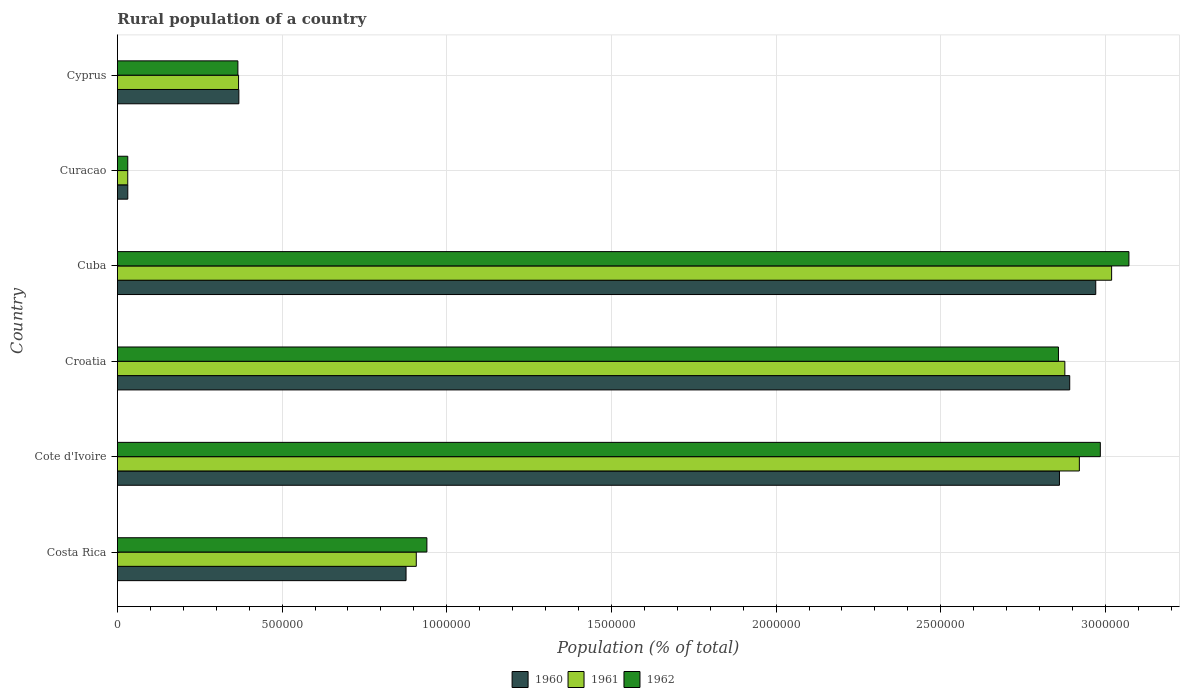How many different coloured bars are there?
Provide a short and direct response. 3. How many groups of bars are there?
Ensure brevity in your answer.  6. Are the number of bars on each tick of the Y-axis equal?
Your answer should be compact. Yes. What is the label of the 4th group of bars from the top?
Your response must be concise. Croatia. What is the rural population in 1961 in Croatia?
Ensure brevity in your answer.  2.88e+06. Across all countries, what is the maximum rural population in 1960?
Your answer should be compact. 2.97e+06. Across all countries, what is the minimum rural population in 1962?
Ensure brevity in your answer.  3.15e+04. In which country was the rural population in 1960 maximum?
Make the answer very short. Cuba. In which country was the rural population in 1961 minimum?
Ensure brevity in your answer.  Curacao. What is the total rural population in 1961 in the graph?
Your answer should be compact. 1.01e+07. What is the difference between the rural population in 1962 in Costa Rica and that in Cyprus?
Provide a succinct answer. 5.74e+05. What is the difference between the rural population in 1961 in Cyprus and the rural population in 1960 in Costa Rica?
Ensure brevity in your answer.  -5.09e+05. What is the average rural population in 1961 per country?
Provide a short and direct response. 1.69e+06. What is the difference between the rural population in 1962 and rural population in 1961 in Cuba?
Make the answer very short. 5.25e+04. What is the ratio of the rural population in 1961 in Costa Rica to that in Croatia?
Your answer should be very brief. 0.32. What is the difference between the highest and the second highest rural population in 1961?
Your answer should be compact. 9.80e+04. What is the difference between the highest and the lowest rural population in 1960?
Keep it short and to the point. 2.94e+06. What does the 3rd bar from the top in Cote d'Ivoire represents?
Give a very brief answer. 1960. Is it the case that in every country, the sum of the rural population in 1960 and rural population in 1961 is greater than the rural population in 1962?
Give a very brief answer. Yes. Are the values on the major ticks of X-axis written in scientific E-notation?
Ensure brevity in your answer.  No. Where does the legend appear in the graph?
Offer a very short reply. Bottom center. How many legend labels are there?
Offer a terse response. 3. What is the title of the graph?
Keep it short and to the point. Rural population of a country. Does "1993" appear as one of the legend labels in the graph?
Your answer should be compact. No. What is the label or title of the X-axis?
Offer a terse response. Population (% of total). What is the Population (% of total) in 1960 in Costa Rica?
Your answer should be very brief. 8.76e+05. What is the Population (% of total) in 1961 in Costa Rica?
Offer a terse response. 9.08e+05. What is the Population (% of total) in 1962 in Costa Rica?
Your answer should be compact. 9.40e+05. What is the Population (% of total) in 1960 in Cote d'Ivoire?
Ensure brevity in your answer.  2.86e+06. What is the Population (% of total) in 1961 in Cote d'Ivoire?
Make the answer very short. 2.92e+06. What is the Population (% of total) of 1962 in Cote d'Ivoire?
Give a very brief answer. 2.98e+06. What is the Population (% of total) of 1960 in Croatia?
Provide a short and direct response. 2.89e+06. What is the Population (% of total) in 1961 in Croatia?
Offer a very short reply. 2.88e+06. What is the Population (% of total) of 1962 in Croatia?
Keep it short and to the point. 2.86e+06. What is the Population (% of total) in 1960 in Cuba?
Keep it short and to the point. 2.97e+06. What is the Population (% of total) in 1961 in Cuba?
Provide a succinct answer. 3.02e+06. What is the Population (% of total) in 1962 in Cuba?
Offer a terse response. 3.07e+06. What is the Population (% of total) in 1960 in Curacao?
Offer a terse response. 3.16e+04. What is the Population (% of total) in 1961 in Curacao?
Offer a terse response. 3.14e+04. What is the Population (% of total) of 1962 in Curacao?
Provide a succinct answer. 3.15e+04. What is the Population (% of total) in 1960 in Cyprus?
Provide a short and direct response. 3.69e+05. What is the Population (% of total) in 1961 in Cyprus?
Make the answer very short. 3.68e+05. What is the Population (% of total) in 1962 in Cyprus?
Keep it short and to the point. 3.66e+05. Across all countries, what is the maximum Population (% of total) in 1960?
Ensure brevity in your answer.  2.97e+06. Across all countries, what is the maximum Population (% of total) of 1961?
Provide a succinct answer. 3.02e+06. Across all countries, what is the maximum Population (% of total) in 1962?
Provide a short and direct response. 3.07e+06. Across all countries, what is the minimum Population (% of total) in 1960?
Your response must be concise. 3.16e+04. Across all countries, what is the minimum Population (% of total) in 1961?
Your answer should be very brief. 3.14e+04. Across all countries, what is the minimum Population (% of total) in 1962?
Keep it short and to the point. 3.15e+04. What is the total Population (% of total) of 1960 in the graph?
Offer a terse response. 1.00e+07. What is the total Population (% of total) of 1961 in the graph?
Offer a very short reply. 1.01e+07. What is the total Population (% of total) of 1962 in the graph?
Your response must be concise. 1.03e+07. What is the difference between the Population (% of total) of 1960 in Costa Rica and that in Cote d'Ivoire?
Give a very brief answer. -1.98e+06. What is the difference between the Population (% of total) of 1961 in Costa Rica and that in Cote d'Ivoire?
Your answer should be compact. -2.01e+06. What is the difference between the Population (% of total) of 1962 in Costa Rica and that in Cote d'Ivoire?
Ensure brevity in your answer.  -2.04e+06. What is the difference between the Population (% of total) in 1960 in Costa Rica and that in Croatia?
Your answer should be compact. -2.02e+06. What is the difference between the Population (% of total) of 1961 in Costa Rica and that in Croatia?
Make the answer very short. -1.97e+06. What is the difference between the Population (% of total) in 1962 in Costa Rica and that in Croatia?
Your response must be concise. -1.92e+06. What is the difference between the Population (% of total) of 1960 in Costa Rica and that in Cuba?
Your answer should be very brief. -2.09e+06. What is the difference between the Population (% of total) of 1961 in Costa Rica and that in Cuba?
Keep it short and to the point. -2.11e+06. What is the difference between the Population (% of total) of 1962 in Costa Rica and that in Cuba?
Provide a short and direct response. -2.13e+06. What is the difference between the Population (% of total) of 1960 in Costa Rica and that in Curacao?
Your answer should be compact. 8.45e+05. What is the difference between the Population (% of total) of 1961 in Costa Rica and that in Curacao?
Keep it short and to the point. 8.76e+05. What is the difference between the Population (% of total) in 1962 in Costa Rica and that in Curacao?
Your answer should be very brief. 9.08e+05. What is the difference between the Population (% of total) of 1960 in Costa Rica and that in Cyprus?
Provide a short and direct response. 5.08e+05. What is the difference between the Population (% of total) in 1961 in Costa Rica and that in Cyprus?
Give a very brief answer. 5.40e+05. What is the difference between the Population (% of total) in 1962 in Costa Rica and that in Cyprus?
Ensure brevity in your answer.  5.74e+05. What is the difference between the Population (% of total) of 1960 in Cote d'Ivoire and that in Croatia?
Your answer should be compact. -3.12e+04. What is the difference between the Population (% of total) of 1961 in Cote d'Ivoire and that in Croatia?
Your answer should be very brief. 4.41e+04. What is the difference between the Population (% of total) in 1962 in Cote d'Ivoire and that in Croatia?
Offer a terse response. 1.27e+05. What is the difference between the Population (% of total) in 1960 in Cote d'Ivoire and that in Cuba?
Make the answer very short. -1.10e+05. What is the difference between the Population (% of total) in 1961 in Cote d'Ivoire and that in Cuba?
Offer a terse response. -9.80e+04. What is the difference between the Population (% of total) of 1962 in Cote d'Ivoire and that in Cuba?
Your response must be concise. -8.68e+04. What is the difference between the Population (% of total) of 1960 in Cote d'Ivoire and that in Curacao?
Ensure brevity in your answer.  2.83e+06. What is the difference between the Population (% of total) in 1961 in Cote d'Ivoire and that in Curacao?
Your answer should be compact. 2.89e+06. What is the difference between the Population (% of total) of 1962 in Cote d'Ivoire and that in Curacao?
Provide a succinct answer. 2.95e+06. What is the difference between the Population (% of total) in 1960 in Cote d'Ivoire and that in Cyprus?
Ensure brevity in your answer.  2.49e+06. What is the difference between the Population (% of total) in 1961 in Cote d'Ivoire and that in Cyprus?
Your answer should be compact. 2.55e+06. What is the difference between the Population (% of total) of 1962 in Cote d'Ivoire and that in Cyprus?
Offer a very short reply. 2.62e+06. What is the difference between the Population (% of total) of 1960 in Croatia and that in Cuba?
Provide a short and direct response. -7.90e+04. What is the difference between the Population (% of total) in 1961 in Croatia and that in Cuba?
Give a very brief answer. -1.42e+05. What is the difference between the Population (% of total) in 1962 in Croatia and that in Cuba?
Offer a very short reply. -2.14e+05. What is the difference between the Population (% of total) of 1960 in Croatia and that in Curacao?
Make the answer very short. 2.86e+06. What is the difference between the Population (% of total) of 1961 in Croatia and that in Curacao?
Your answer should be compact. 2.85e+06. What is the difference between the Population (% of total) of 1962 in Croatia and that in Curacao?
Your answer should be compact. 2.83e+06. What is the difference between the Population (% of total) of 1960 in Croatia and that in Cyprus?
Provide a short and direct response. 2.52e+06. What is the difference between the Population (% of total) of 1961 in Croatia and that in Cyprus?
Offer a terse response. 2.51e+06. What is the difference between the Population (% of total) in 1962 in Croatia and that in Cyprus?
Your response must be concise. 2.49e+06. What is the difference between the Population (% of total) of 1960 in Cuba and that in Curacao?
Provide a succinct answer. 2.94e+06. What is the difference between the Population (% of total) of 1961 in Cuba and that in Curacao?
Provide a short and direct response. 2.99e+06. What is the difference between the Population (% of total) in 1962 in Cuba and that in Curacao?
Your response must be concise. 3.04e+06. What is the difference between the Population (% of total) in 1960 in Cuba and that in Cyprus?
Your answer should be compact. 2.60e+06. What is the difference between the Population (% of total) of 1961 in Cuba and that in Cyprus?
Provide a succinct answer. 2.65e+06. What is the difference between the Population (% of total) in 1962 in Cuba and that in Cyprus?
Your response must be concise. 2.71e+06. What is the difference between the Population (% of total) of 1960 in Curacao and that in Cyprus?
Your answer should be compact. -3.37e+05. What is the difference between the Population (% of total) of 1961 in Curacao and that in Cyprus?
Make the answer very short. -3.36e+05. What is the difference between the Population (% of total) in 1962 in Curacao and that in Cyprus?
Give a very brief answer. -3.34e+05. What is the difference between the Population (% of total) in 1960 in Costa Rica and the Population (% of total) in 1961 in Cote d'Ivoire?
Offer a very short reply. -2.04e+06. What is the difference between the Population (% of total) in 1960 in Costa Rica and the Population (% of total) in 1962 in Cote d'Ivoire?
Provide a short and direct response. -2.11e+06. What is the difference between the Population (% of total) of 1961 in Costa Rica and the Population (% of total) of 1962 in Cote d'Ivoire?
Offer a terse response. -2.08e+06. What is the difference between the Population (% of total) of 1960 in Costa Rica and the Population (% of total) of 1961 in Croatia?
Offer a terse response. -2.00e+06. What is the difference between the Population (% of total) in 1960 in Costa Rica and the Population (% of total) in 1962 in Croatia?
Provide a succinct answer. -1.98e+06. What is the difference between the Population (% of total) in 1961 in Costa Rica and the Population (% of total) in 1962 in Croatia?
Your answer should be compact. -1.95e+06. What is the difference between the Population (% of total) in 1960 in Costa Rica and the Population (% of total) in 1961 in Cuba?
Your answer should be compact. -2.14e+06. What is the difference between the Population (% of total) of 1960 in Costa Rica and the Population (% of total) of 1962 in Cuba?
Offer a very short reply. -2.19e+06. What is the difference between the Population (% of total) in 1961 in Costa Rica and the Population (% of total) in 1962 in Cuba?
Your answer should be compact. -2.16e+06. What is the difference between the Population (% of total) in 1960 in Costa Rica and the Population (% of total) in 1961 in Curacao?
Your answer should be compact. 8.45e+05. What is the difference between the Population (% of total) of 1960 in Costa Rica and the Population (% of total) of 1962 in Curacao?
Keep it short and to the point. 8.45e+05. What is the difference between the Population (% of total) in 1961 in Costa Rica and the Population (% of total) in 1962 in Curacao?
Your answer should be compact. 8.76e+05. What is the difference between the Population (% of total) in 1960 in Costa Rica and the Population (% of total) in 1961 in Cyprus?
Your answer should be very brief. 5.09e+05. What is the difference between the Population (% of total) of 1960 in Costa Rica and the Population (% of total) of 1962 in Cyprus?
Your answer should be compact. 5.11e+05. What is the difference between the Population (% of total) in 1961 in Costa Rica and the Population (% of total) in 1962 in Cyprus?
Your answer should be very brief. 5.42e+05. What is the difference between the Population (% of total) in 1960 in Cote d'Ivoire and the Population (% of total) in 1961 in Croatia?
Offer a very short reply. -1.64e+04. What is the difference between the Population (% of total) of 1960 in Cote d'Ivoire and the Population (% of total) of 1962 in Croatia?
Provide a short and direct response. 3039. What is the difference between the Population (% of total) in 1961 in Cote d'Ivoire and the Population (% of total) in 1962 in Croatia?
Offer a very short reply. 6.35e+04. What is the difference between the Population (% of total) in 1960 in Cote d'Ivoire and the Population (% of total) in 1961 in Cuba?
Offer a very short reply. -1.58e+05. What is the difference between the Population (% of total) of 1960 in Cote d'Ivoire and the Population (% of total) of 1962 in Cuba?
Your answer should be compact. -2.11e+05. What is the difference between the Population (% of total) in 1961 in Cote d'Ivoire and the Population (% of total) in 1962 in Cuba?
Your answer should be very brief. -1.50e+05. What is the difference between the Population (% of total) in 1960 in Cote d'Ivoire and the Population (% of total) in 1961 in Curacao?
Keep it short and to the point. 2.83e+06. What is the difference between the Population (% of total) in 1960 in Cote d'Ivoire and the Population (% of total) in 1962 in Curacao?
Provide a short and direct response. 2.83e+06. What is the difference between the Population (% of total) of 1961 in Cote d'Ivoire and the Population (% of total) of 1962 in Curacao?
Offer a very short reply. 2.89e+06. What is the difference between the Population (% of total) of 1960 in Cote d'Ivoire and the Population (% of total) of 1961 in Cyprus?
Make the answer very short. 2.49e+06. What is the difference between the Population (% of total) in 1960 in Cote d'Ivoire and the Population (% of total) in 1962 in Cyprus?
Your answer should be very brief. 2.49e+06. What is the difference between the Population (% of total) in 1961 in Cote d'Ivoire and the Population (% of total) in 1962 in Cyprus?
Keep it short and to the point. 2.56e+06. What is the difference between the Population (% of total) in 1960 in Croatia and the Population (% of total) in 1961 in Cuba?
Your answer should be compact. -1.27e+05. What is the difference between the Population (% of total) in 1960 in Croatia and the Population (% of total) in 1962 in Cuba?
Keep it short and to the point. -1.80e+05. What is the difference between the Population (% of total) in 1961 in Croatia and the Population (% of total) in 1962 in Cuba?
Keep it short and to the point. -1.95e+05. What is the difference between the Population (% of total) of 1960 in Croatia and the Population (% of total) of 1961 in Curacao?
Your answer should be very brief. 2.86e+06. What is the difference between the Population (% of total) of 1960 in Croatia and the Population (% of total) of 1962 in Curacao?
Ensure brevity in your answer.  2.86e+06. What is the difference between the Population (% of total) of 1961 in Croatia and the Population (% of total) of 1962 in Curacao?
Offer a very short reply. 2.85e+06. What is the difference between the Population (% of total) in 1960 in Croatia and the Population (% of total) in 1961 in Cyprus?
Your response must be concise. 2.52e+06. What is the difference between the Population (% of total) in 1960 in Croatia and the Population (% of total) in 1962 in Cyprus?
Offer a very short reply. 2.53e+06. What is the difference between the Population (% of total) of 1961 in Croatia and the Population (% of total) of 1962 in Cyprus?
Offer a terse response. 2.51e+06. What is the difference between the Population (% of total) in 1960 in Cuba and the Population (% of total) in 1961 in Curacao?
Provide a succinct answer. 2.94e+06. What is the difference between the Population (% of total) of 1960 in Cuba and the Population (% of total) of 1962 in Curacao?
Provide a succinct answer. 2.94e+06. What is the difference between the Population (% of total) of 1961 in Cuba and the Population (% of total) of 1962 in Curacao?
Make the answer very short. 2.99e+06. What is the difference between the Population (% of total) of 1960 in Cuba and the Population (% of total) of 1961 in Cyprus?
Offer a very short reply. 2.60e+06. What is the difference between the Population (% of total) of 1960 in Cuba and the Population (% of total) of 1962 in Cyprus?
Give a very brief answer. 2.60e+06. What is the difference between the Population (% of total) in 1961 in Cuba and the Population (% of total) in 1962 in Cyprus?
Provide a short and direct response. 2.65e+06. What is the difference between the Population (% of total) of 1960 in Curacao and the Population (% of total) of 1961 in Cyprus?
Your answer should be very brief. -3.36e+05. What is the difference between the Population (% of total) in 1960 in Curacao and the Population (% of total) in 1962 in Cyprus?
Offer a terse response. -3.34e+05. What is the difference between the Population (% of total) in 1961 in Curacao and the Population (% of total) in 1962 in Cyprus?
Ensure brevity in your answer.  -3.34e+05. What is the average Population (% of total) in 1960 per country?
Keep it short and to the point. 1.67e+06. What is the average Population (% of total) of 1961 per country?
Your answer should be compact. 1.69e+06. What is the average Population (% of total) in 1962 per country?
Offer a very short reply. 1.71e+06. What is the difference between the Population (% of total) of 1960 and Population (% of total) of 1961 in Costa Rica?
Provide a succinct answer. -3.11e+04. What is the difference between the Population (% of total) of 1960 and Population (% of total) of 1962 in Costa Rica?
Provide a short and direct response. -6.33e+04. What is the difference between the Population (% of total) in 1961 and Population (% of total) in 1962 in Costa Rica?
Offer a terse response. -3.22e+04. What is the difference between the Population (% of total) in 1960 and Population (% of total) in 1961 in Cote d'Ivoire?
Your answer should be compact. -6.05e+04. What is the difference between the Population (% of total) in 1960 and Population (% of total) in 1962 in Cote d'Ivoire?
Your response must be concise. -1.24e+05. What is the difference between the Population (% of total) in 1961 and Population (% of total) in 1962 in Cote d'Ivoire?
Make the answer very short. -6.37e+04. What is the difference between the Population (% of total) in 1960 and Population (% of total) in 1961 in Croatia?
Make the answer very short. 1.48e+04. What is the difference between the Population (% of total) in 1960 and Population (% of total) in 1962 in Croatia?
Provide a short and direct response. 3.42e+04. What is the difference between the Population (% of total) of 1961 and Population (% of total) of 1962 in Croatia?
Your response must be concise. 1.94e+04. What is the difference between the Population (% of total) in 1960 and Population (% of total) in 1961 in Cuba?
Your response must be concise. -4.82e+04. What is the difference between the Population (% of total) in 1960 and Population (% of total) in 1962 in Cuba?
Your response must be concise. -1.01e+05. What is the difference between the Population (% of total) of 1961 and Population (% of total) of 1962 in Cuba?
Your answer should be compact. -5.25e+04. What is the difference between the Population (% of total) in 1960 and Population (% of total) in 1961 in Curacao?
Make the answer very short. 165. What is the difference between the Population (% of total) of 1960 and Population (% of total) of 1962 in Curacao?
Offer a terse response. 94. What is the difference between the Population (% of total) in 1961 and Population (% of total) in 1962 in Curacao?
Your answer should be compact. -71. What is the difference between the Population (% of total) in 1960 and Population (% of total) in 1961 in Cyprus?
Make the answer very short. 922. What is the difference between the Population (% of total) in 1960 and Population (% of total) in 1962 in Cyprus?
Keep it short and to the point. 2977. What is the difference between the Population (% of total) of 1961 and Population (% of total) of 1962 in Cyprus?
Your answer should be compact. 2055. What is the ratio of the Population (% of total) of 1960 in Costa Rica to that in Cote d'Ivoire?
Provide a short and direct response. 0.31. What is the ratio of the Population (% of total) of 1961 in Costa Rica to that in Cote d'Ivoire?
Keep it short and to the point. 0.31. What is the ratio of the Population (% of total) in 1962 in Costa Rica to that in Cote d'Ivoire?
Your answer should be compact. 0.31. What is the ratio of the Population (% of total) of 1960 in Costa Rica to that in Croatia?
Provide a succinct answer. 0.3. What is the ratio of the Population (% of total) in 1961 in Costa Rica to that in Croatia?
Offer a terse response. 0.32. What is the ratio of the Population (% of total) of 1962 in Costa Rica to that in Croatia?
Provide a short and direct response. 0.33. What is the ratio of the Population (% of total) in 1960 in Costa Rica to that in Cuba?
Offer a terse response. 0.29. What is the ratio of the Population (% of total) in 1961 in Costa Rica to that in Cuba?
Offer a terse response. 0.3. What is the ratio of the Population (% of total) of 1962 in Costa Rica to that in Cuba?
Offer a terse response. 0.31. What is the ratio of the Population (% of total) in 1960 in Costa Rica to that in Curacao?
Your answer should be very brief. 27.76. What is the ratio of the Population (% of total) of 1961 in Costa Rica to that in Curacao?
Ensure brevity in your answer.  28.9. What is the ratio of the Population (% of total) of 1962 in Costa Rica to that in Curacao?
Give a very brief answer. 29.86. What is the ratio of the Population (% of total) in 1960 in Costa Rica to that in Cyprus?
Give a very brief answer. 2.38. What is the ratio of the Population (% of total) of 1961 in Costa Rica to that in Cyprus?
Keep it short and to the point. 2.47. What is the ratio of the Population (% of total) in 1962 in Costa Rica to that in Cyprus?
Your answer should be compact. 2.57. What is the ratio of the Population (% of total) in 1961 in Cote d'Ivoire to that in Croatia?
Keep it short and to the point. 1.02. What is the ratio of the Population (% of total) of 1962 in Cote d'Ivoire to that in Croatia?
Keep it short and to the point. 1.04. What is the ratio of the Population (% of total) of 1960 in Cote d'Ivoire to that in Cuba?
Give a very brief answer. 0.96. What is the ratio of the Population (% of total) in 1961 in Cote d'Ivoire to that in Cuba?
Your answer should be compact. 0.97. What is the ratio of the Population (% of total) of 1962 in Cote d'Ivoire to that in Cuba?
Offer a very short reply. 0.97. What is the ratio of the Population (% of total) of 1960 in Cote d'Ivoire to that in Curacao?
Offer a very short reply. 90.61. What is the ratio of the Population (% of total) in 1961 in Cote d'Ivoire to that in Curacao?
Your answer should be compact. 93.01. What is the ratio of the Population (% of total) of 1962 in Cote d'Ivoire to that in Curacao?
Offer a very short reply. 94.83. What is the ratio of the Population (% of total) of 1960 in Cote d'Ivoire to that in Cyprus?
Make the answer very short. 7.76. What is the ratio of the Population (% of total) of 1961 in Cote d'Ivoire to that in Cyprus?
Keep it short and to the point. 7.94. What is the ratio of the Population (% of total) in 1962 in Cote d'Ivoire to that in Cyprus?
Your answer should be very brief. 8.16. What is the ratio of the Population (% of total) of 1960 in Croatia to that in Cuba?
Ensure brevity in your answer.  0.97. What is the ratio of the Population (% of total) of 1961 in Croatia to that in Cuba?
Give a very brief answer. 0.95. What is the ratio of the Population (% of total) in 1962 in Croatia to that in Cuba?
Provide a succinct answer. 0.93. What is the ratio of the Population (% of total) of 1960 in Croatia to that in Curacao?
Give a very brief answer. 91.6. What is the ratio of the Population (% of total) of 1961 in Croatia to that in Curacao?
Provide a succinct answer. 91.61. What is the ratio of the Population (% of total) of 1962 in Croatia to that in Curacao?
Offer a very short reply. 90.79. What is the ratio of the Population (% of total) of 1960 in Croatia to that in Cyprus?
Your response must be concise. 7.84. What is the ratio of the Population (% of total) in 1961 in Croatia to that in Cyprus?
Provide a succinct answer. 7.82. What is the ratio of the Population (% of total) of 1962 in Croatia to that in Cyprus?
Your response must be concise. 7.81. What is the ratio of the Population (% of total) of 1960 in Cuba to that in Curacao?
Provide a succinct answer. 94.1. What is the ratio of the Population (% of total) in 1961 in Cuba to that in Curacao?
Keep it short and to the point. 96.13. What is the ratio of the Population (% of total) in 1962 in Cuba to that in Curacao?
Provide a short and direct response. 97.58. What is the ratio of the Population (% of total) of 1960 in Cuba to that in Cyprus?
Provide a succinct answer. 8.05. What is the ratio of the Population (% of total) in 1961 in Cuba to that in Cyprus?
Offer a terse response. 8.21. What is the ratio of the Population (% of total) of 1962 in Cuba to that in Cyprus?
Ensure brevity in your answer.  8.4. What is the ratio of the Population (% of total) in 1960 in Curacao to that in Cyprus?
Ensure brevity in your answer.  0.09. What is the ratio of the Population (% of total) of 1961 in Curacao to that in Cyprus?
Offer a terse response. 0.09. What is the ratio of the Population (% of total) in 1962 in Curacao to that in Cyprus?
Keep it short and to the point. 0.09. What is the difference between the highest and the second highest Population (% of total) of 1960?
Give a very brief answer. 7.90e+04. What is the difference between the highest and the second highest Population (% of total) in 1961?
Offer a terse response. 9.80e+04. What is the difference between the highest and the second highest Population (% of total) of 1962?
Keep it short and to the point. 8.68e+04. What is the difference between the highest and the lowest Population (% of total) of 1960?
Provide a short and direct response. 2.94e+06. What is the difference between the highest and the lowest Population (% of total) of 1961?
Give a very brief answer. 2.99e+06. What is the difference between the highest and the lowest Population (% of total) in 1962?
Keep it short and to the point. 3.04e+06. 